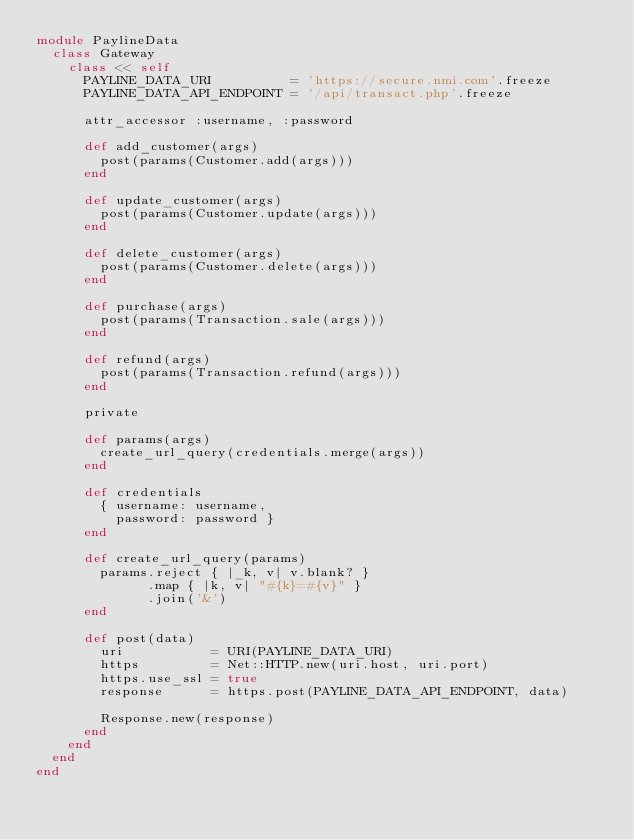Convert code to text. <code><loc_0><loc_0><loc_500><loc_500><_Ruby_>module PaylineData
  class Gateway
    class << self
      PAYLINE_DATA_URI          = 'https://secure.nmi.com'.freeze
      PAYLINE_DATA_API_ENDPOINT = '/api/transact.php'.freeze

      attr_accessor :username, :password

      def add_customer(args)
        post(params(Customer.add(args)))
      end

      def update_customer(args)
        post(params(Customer.update(args)))
      end

      def delete_customer(args)
        post(params(Customer.delete(args)))
      end

      def purchase(args)
        post(params(Transaction.sale(args)))
      end

      def refund(args)
        post(params(Transaction.refund(args)))
      end

      private

      def params(args)
        create_url_query(credentials.merge(args))
      end

      def credentials
        { username: username,
          password: password }
      end

      def create_url_query(params)
        params.reject { |_k, v| v.blank? }
              .map { |k, v| "#{k}=#{v}" }
              .join('&')
      end

      def post(data)
        uri           = URI(PAYLINE_DATA_URI)
        https         = Net::HTTP.new(uri.host, uri.port)
        https.use_ssl = true
        response      = https.post(PAYLINE_DATA_API_ENDPOINT, data)

        Response.new(response)
      end
    end
  end
end
</code> 